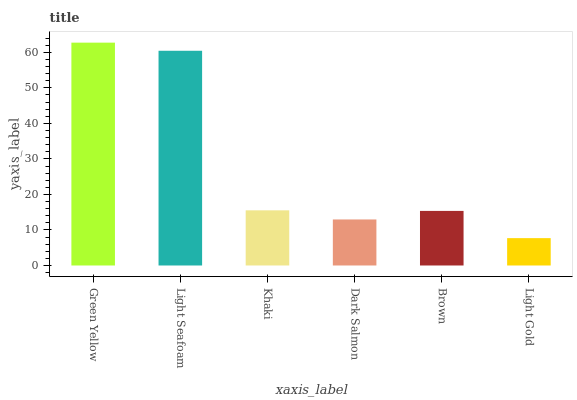Is Light Gold the minimum?
Answer yes or no. Yes. Is Green Yellow the maximum?
Answer yes or no. Yes. Is Light Seafoam the minimum?
Answer yes or no. No. Is Light Seafoam the maximum?
Answer yes or no. No. Is Green Yellow greater than Light Seafoam?
Answer yes or no. Yes. Is Light Seafoam less than Green Yellow?
Answer yes or no. Yes. Is Light Seafoam greater than Green Yellow?
Answer yes or no. No. Is Green Yellow less than Light Seafoam?
Answer yes or no. No. Is Khaki the high median?
Answer yes or no. Yes. Is Brown the low median?
Answer yes or no. Yes. Is Light Gold the high median?
Answer yes or no. No. Is Light Seafoam the low median?
Answer yes or no. No. 